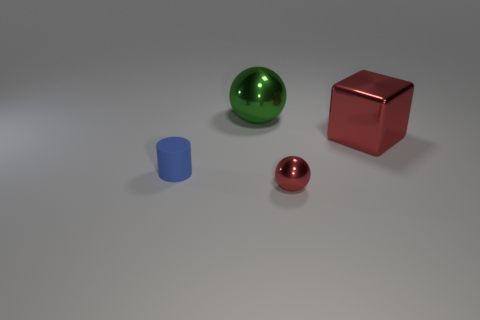Subtract all green balls. How many balls are left? 1 Subtract 1 cylinders. How many cylinders are left? 0 Subtract all cubes. How many objects are left? 3 Subtract all purple cubes. How many red spheres are left? 1 Add 4 small metal balls. How many objects exist? 8 Subtract all blue cylinders. Subtract all big cyan rubber cylinders. How many objects are left? 3 Add 3 cubes. How many cubes are left? 4 Add 1 tiny matte objects. How many tiny matte objects exist? 2 Subtract 0 purple blocks. How many objects are left? 4 Subtract all cyan cylinders. Subtract all yellow spheres. How many cylinders are left? 1 